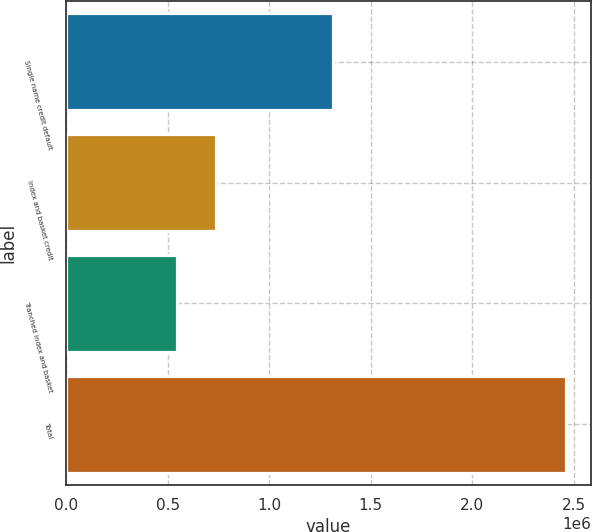Convert chart. <chart><loc_0><loc_0><loc_500><loc_500><bar_chart><fcel>Single name credit default<fcel>Index and basket credit<fcel>Tranched index and basket<fcel>Total<nl><fcel>1.31533e+06<fcel>737154<fcel>545476<fcel>2.46226e+06<nl></chart> 